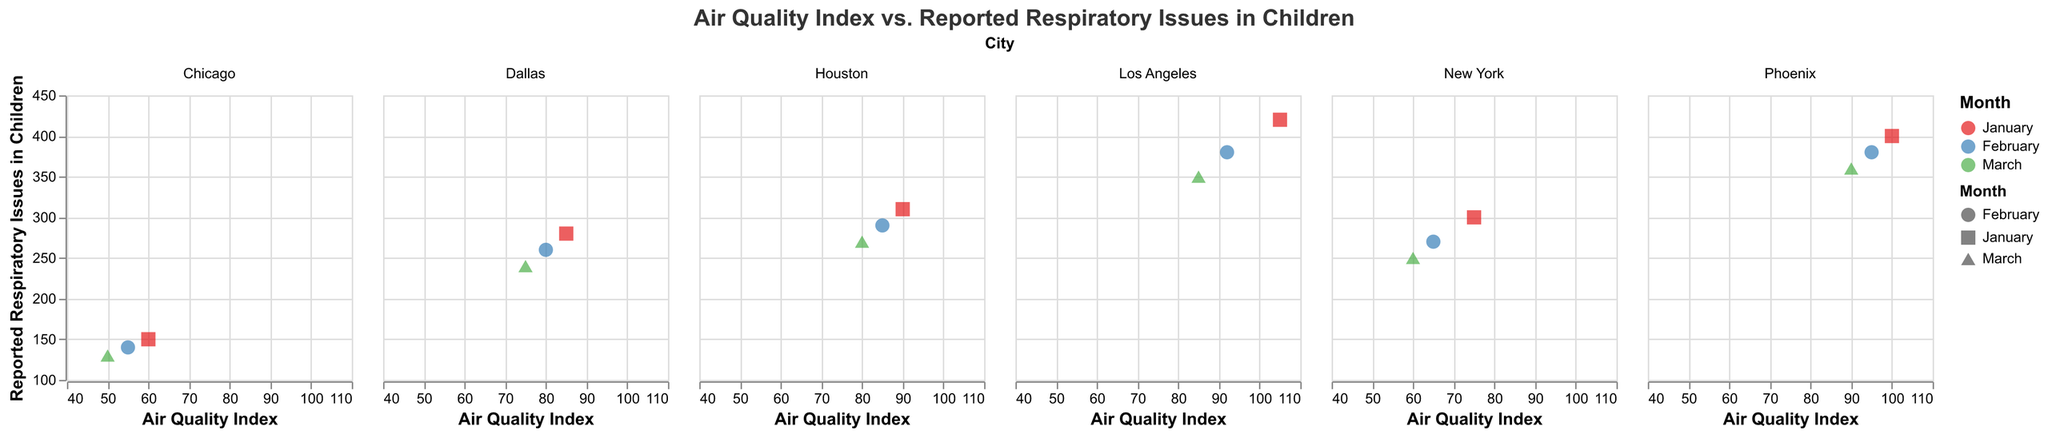How many cities are represented in the figure? The figure is faceted by city, and we observe different subplots for individual cities. To count the cities, look at each facet title. There are six such titles: Los Angeles, New York, Chicago, Houston, Phoenix, and Dallas.
Answer: 6 Which city has the highest reported respiratory issues in children when the air quality index is the worst in January? Look at the data points for January. Los Angeles has the highest data point with 105 AQI and 420 reported respiratory issues.
Answer: Los Angeles Among Los Angeles, Phoenix, and Dallas, which city has the lowest air quality index in March? Compare the AQI for Los Angeles, Phoenix, and Dallas in March. Los Angeles has 85, Phoenix has 90, and Dallas has 75 AQI. Therefore, Dallas has the lowest AQI in March.
Answer: Dallas What is the trend in reported respiratory issues in children in New York from January to March? Observe the trend line or the sequence of points in New York's subplot. The reported respiratory issues in children in New York decrease from 300 in January, to 270 in February, to 250 in March.
Answer: Decreasing If the air quality index in Houston were to worsen to 105 in January, how would its reported respiratory issues compare with Los Angeles for the same month? Check the reported respiratory issues for Los Angeles in January with 105 AQI, which is 420. As the figure does not provide predicated data for Houston at an AQI of 105, direct comparison is speculative. However, Houston's reported respiratory issues are 310 at an AQI of 90.
Answer: Cannot be directly compared with the given data, speculative Is there a consistent correlation between the air quality index and reported respiratory issues in children for any city? Look at each subplot to see if there's a trend line indicating correlation. For Los Angeles and Phoenix, higher AQI correlates with higher reported respiratory issues, while other cities show weaker or no clear correlation.
Answer: Los Angeles and Phoenix show a positive correlation What is the air quality index and reported respiratory issues in children for Chicago with the lowest observation? Refer to the subplot for Chicago, where the point with the lowest AQI is in March, with 50 AQI and reported respiratory issues of 130 children.
Answer: 50 AQI and 130 reported issues Compare the air quality index in February between Chicago and Dallas, and state which city has a lower one and by how much. Chicago's AQI in February is 55, and Dallas's is 80. The difference is 80 - 55 = 25 AQI. Chicago has the lower AQI by 25.
Answer: Chicago, lower by 25 For which months do Los Angeles and Phoenix have the same air quality index? Compare the AQI values across the months for Los Angeles and Phoenix. In March, both cities have an AQI value of 90.
Answer: March Among the plotted points, which city-month combination has the least reported respiratory issues in children, and what are the values? Look for the point with the lowest value on the y-axis across all subplots. Chicago in March has the lowest reported respiratory issues with 130 children.
Answer: Chicago in March with 130 issues 